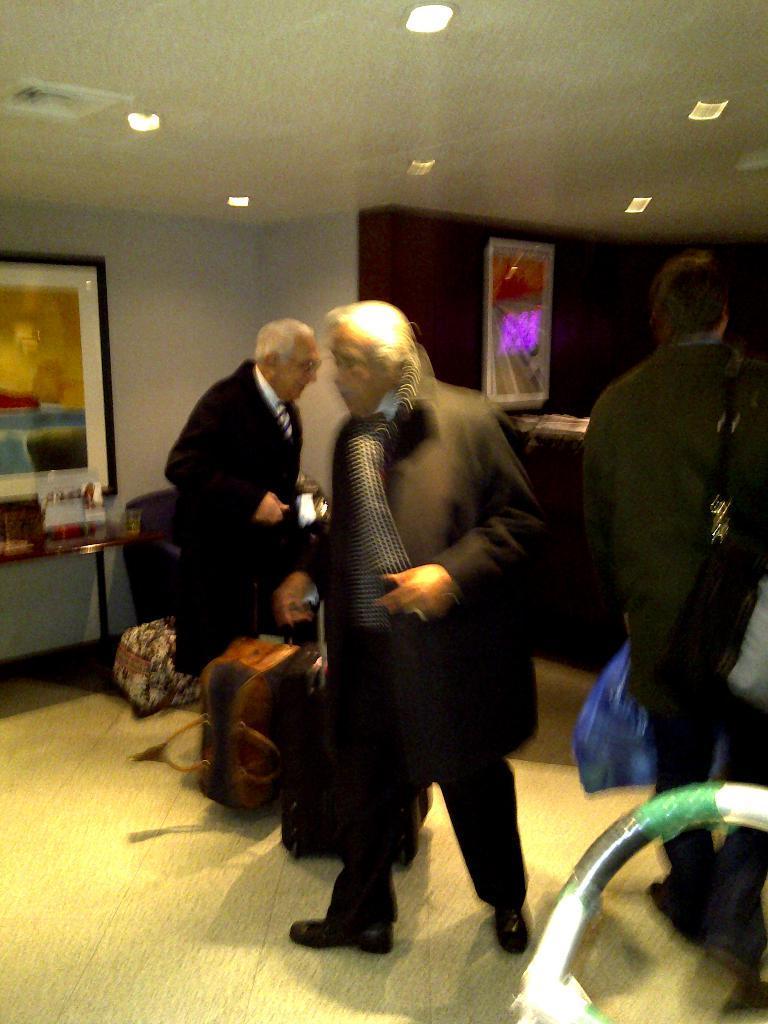Describe this image in one or two sentences. In this image we can see bags on the floor, few persons are standing and a man is walking on the floor. In the background there are frames on the wall, objects on the table and lights on the ceiling. 